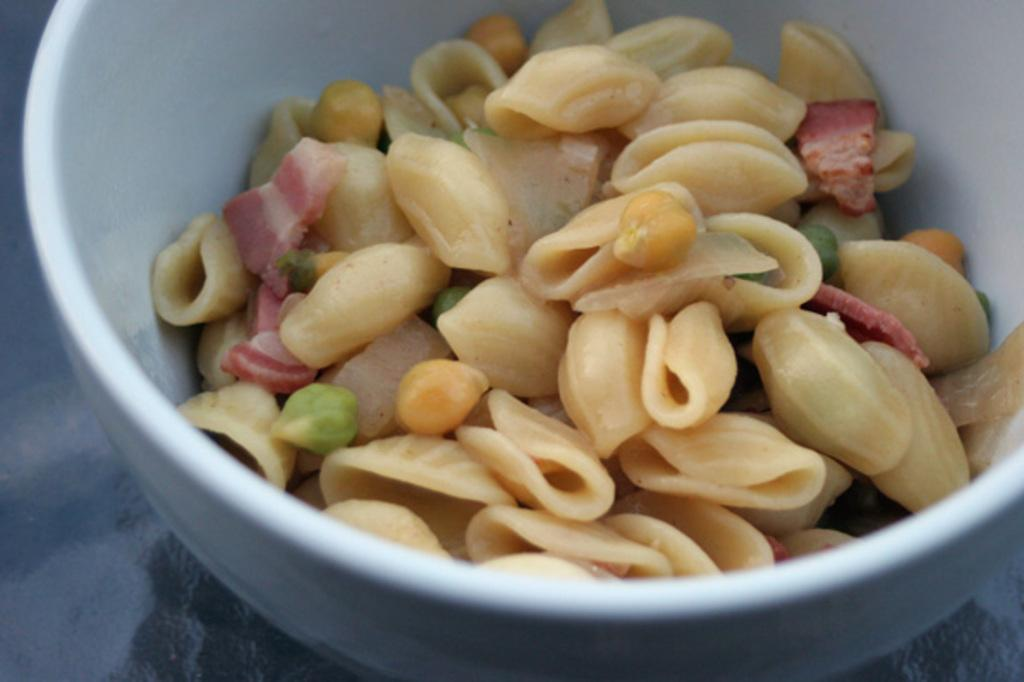What is in the bowl that is visible in the image? There is a bowl in the image, and it contains pasta. What type of food is in the bowl? The bowl contains pasta. Where is the bowl located in the image? The bowl is placed on a surface. What type of coal is being used to heat the pasta in the image? There is no coal present in the image, and the pasta is not being heated. 